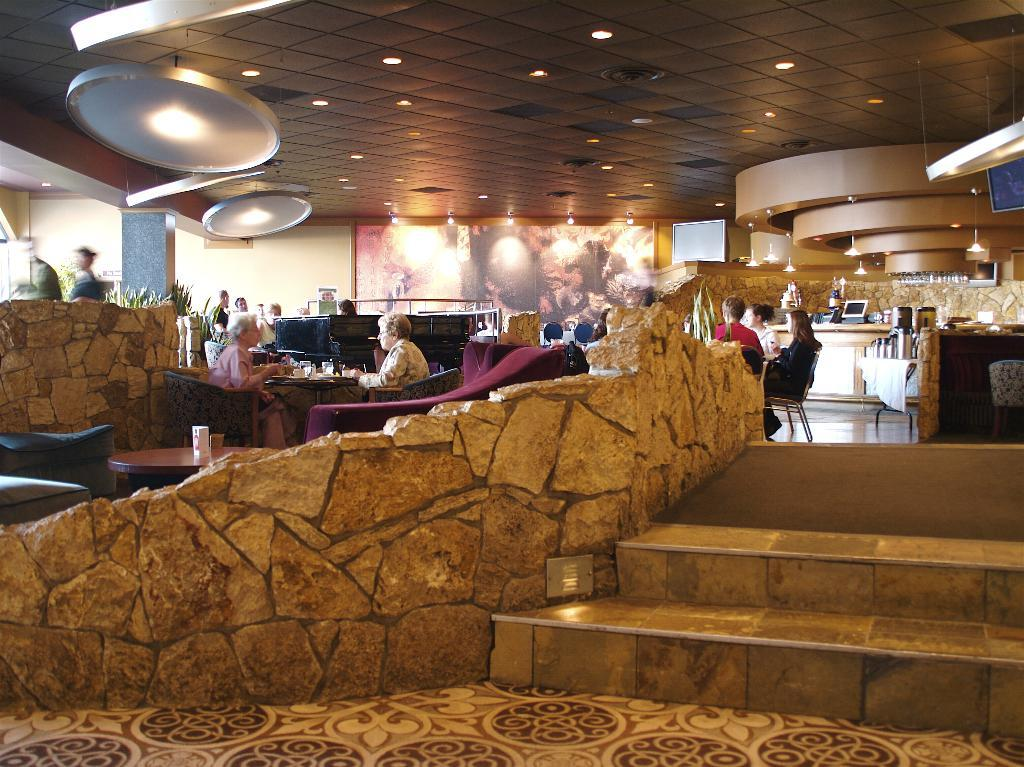What can be seen on the right side of the image? There is a stair on the right side of the image. What is happening on the left side of the image? There are two women sitting on the left side of the image. What type of health advice can be seen in the image? There is no health advice present in the image; it features a stair and two women sitting. What type of collar is being worn by the grandfather in the image? There is no grandfather present in the image, and therefore no collar can be observed. 